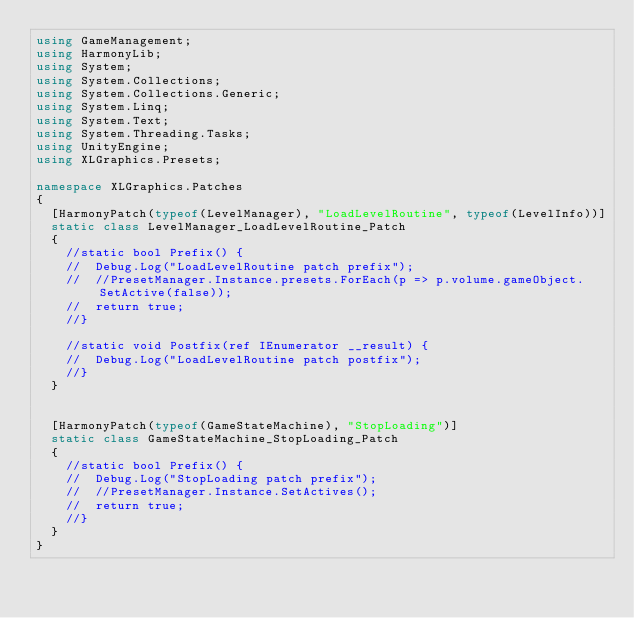<code> <loc_0><loc_0><loc_500><loc_500><_C#_>using GameManagement;
using HarmonyLib;
using System;
using System.Collections;
using System.Collections.Generic;
using System.Linq;
using System.Text;
using System.Threading.Tasks;
using UnityEngine;
using XLGraphics.Presets;

namespace XLGraphics.Patches
{
	[HarmonyPatch(typeof(LevelManager), "LoadLevelRoutine", typeof(LevelInfo))]
	static class LevelManager_LoadLevelRoutine_Patch
	{
		//static bool Prefix() {
		//	Debug.Log("LoadLevelRoutine patch prefix");
		//	//PresetManager.Instance.presets.ForEach(p => p.volume.gameObject.SetActive(false));
		//	return true;
		//}

		//static void Postfix(ref IEnumerator __result) {
		//	Debug.Log("LoadLevelRoutine patch postfix");
		//}
	}


	[HarmonyPatch(typeof(GameStateMachine), "StopLoading")]
	static class GameStateMachine_StopLoading_Patch
	{
		//static bool Prefix() {
		//	Debug.Log("StopLoading patch prefix");
		//	//PresetManager.Instance.SetActives();
		//	return true;
		//}
	}
}
</code> 